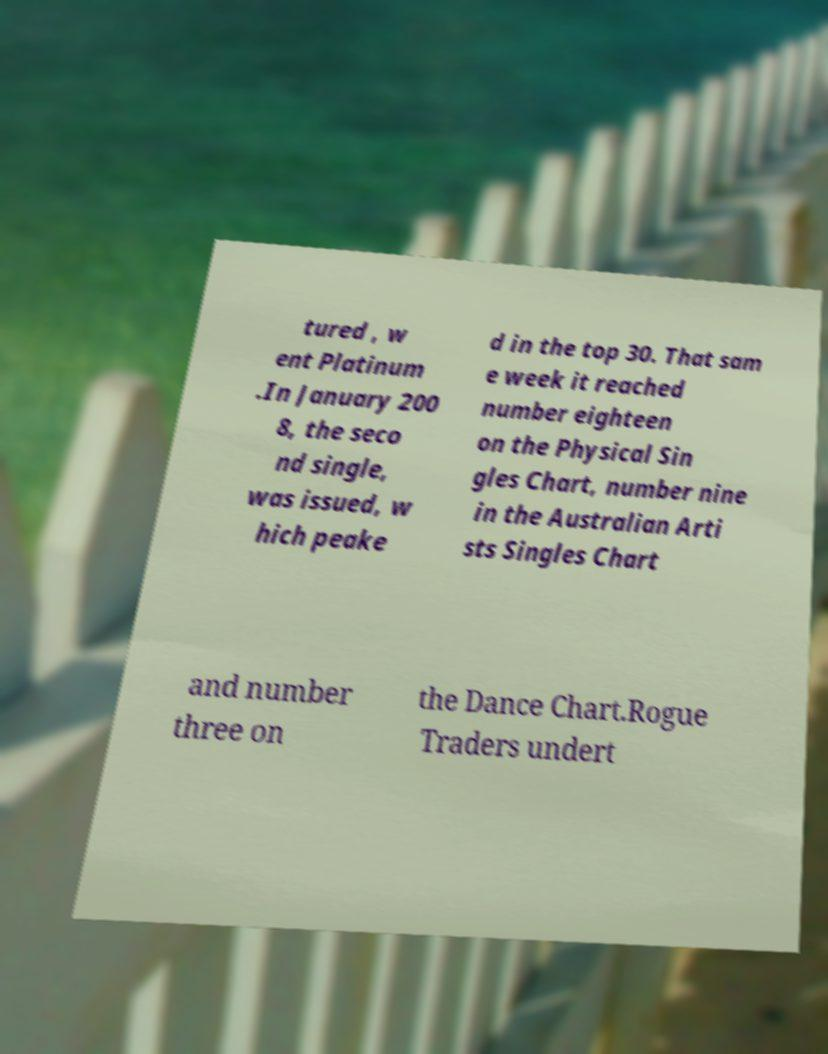There's text embedded in this image that I need extracted. Can you transcribe it verbatim? tured , w ent Platinum .In January 200 8, the seco nd single, was issued, w hich peake d in the top 30. That sam e week it reached number eighteen on the Physical Sin gles Chart, number nine in the Australian Arti sts Singles Chart and number three on the Dance Chart.Rogue Traders undert 